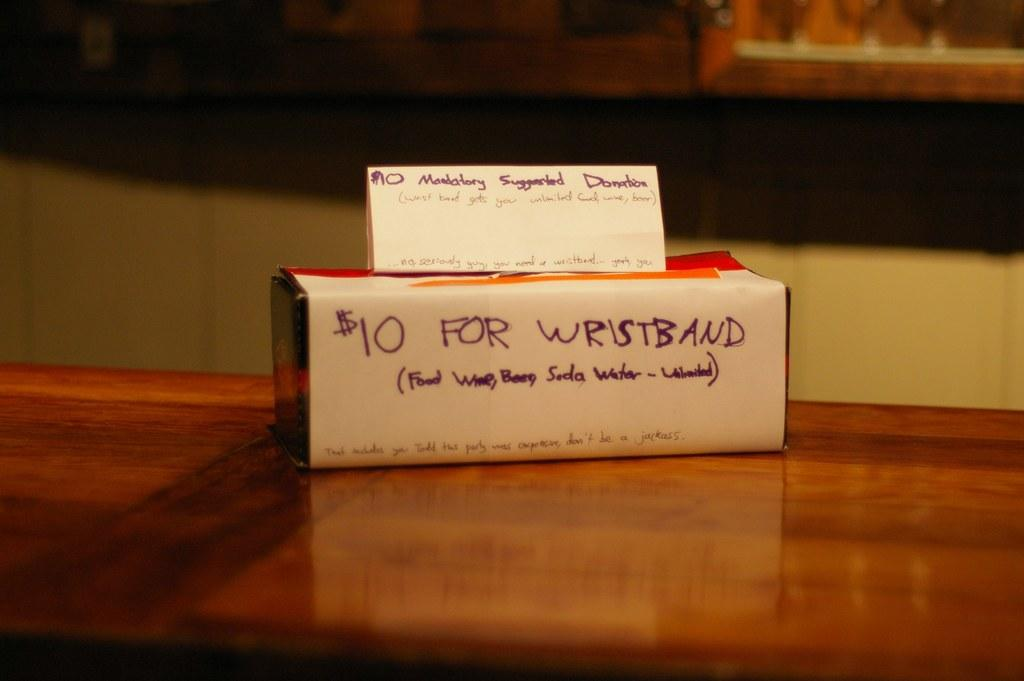<image>
Summarize the visual content of the image. Box with "$10 For Wristband" written on the front. 